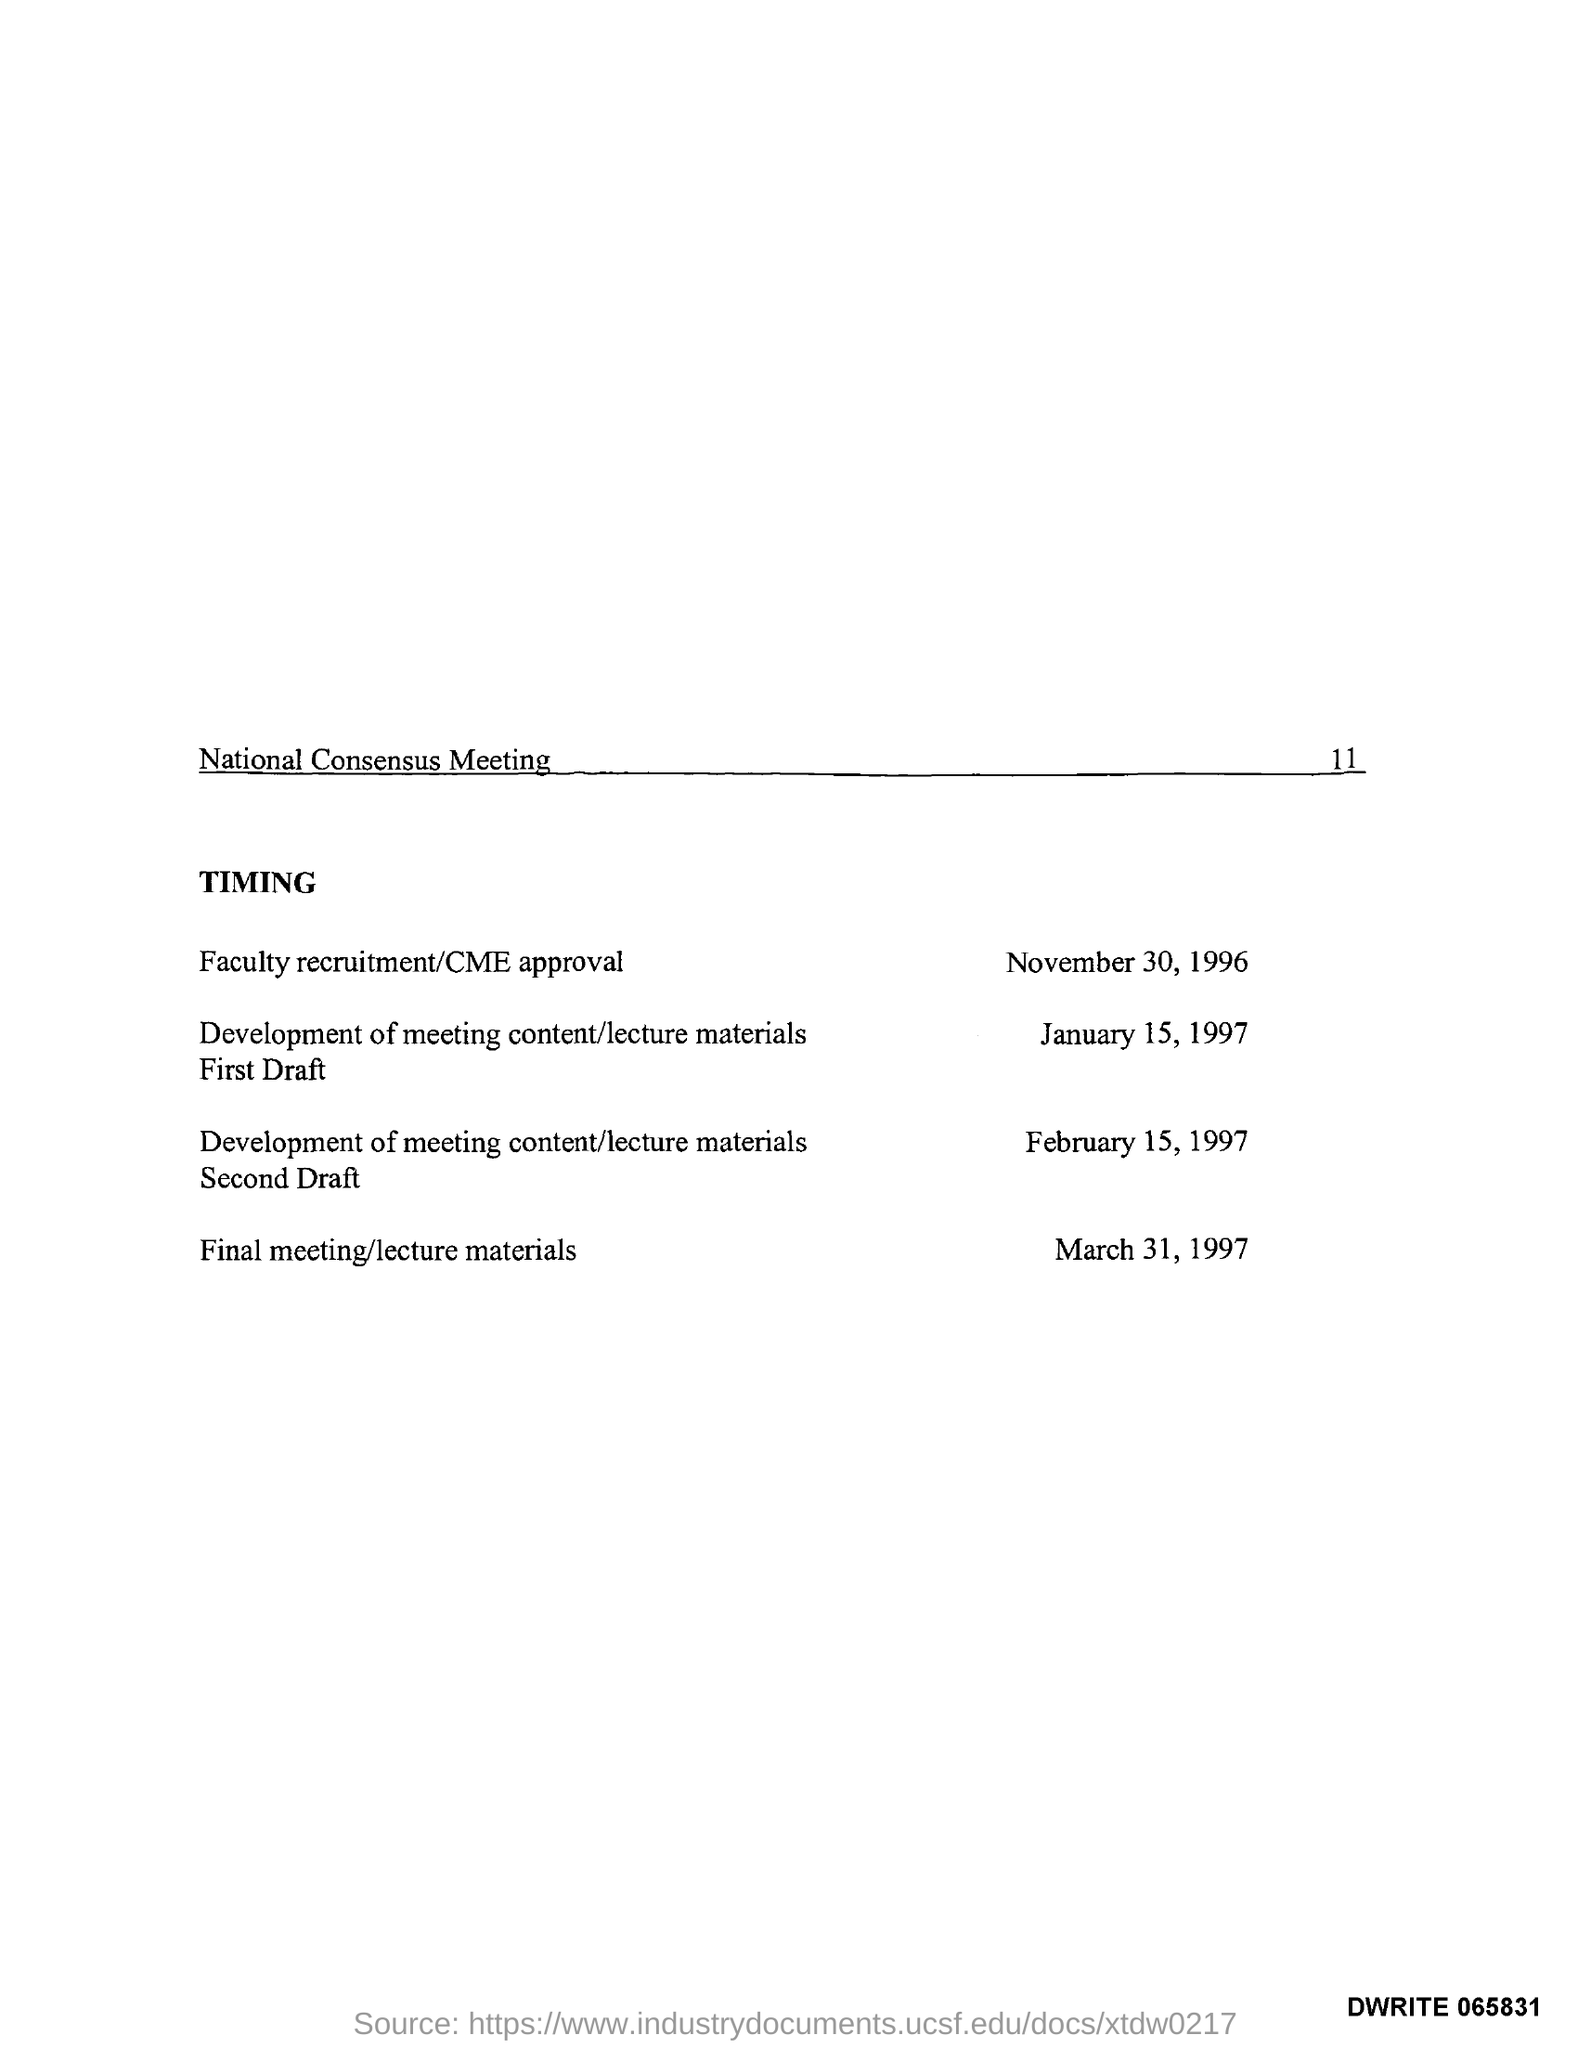What is the Page Number?
Your answer should be compact. 11. 